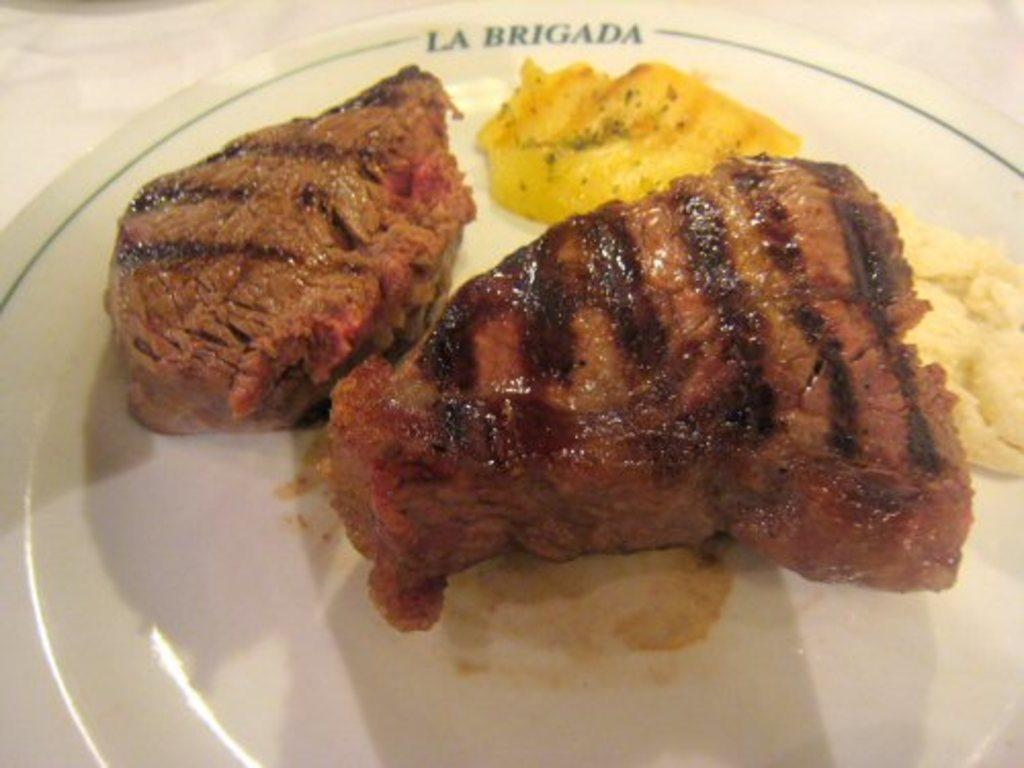What is on the plate that is visible in the image? There is food on a plate in the image. Where is the plate located in the image? The plate is on a platform in the image. How does the development of the food on the plate progress in the image? There is no indication of the development of the food in the image, as it is a static representation of the food on the plate. 